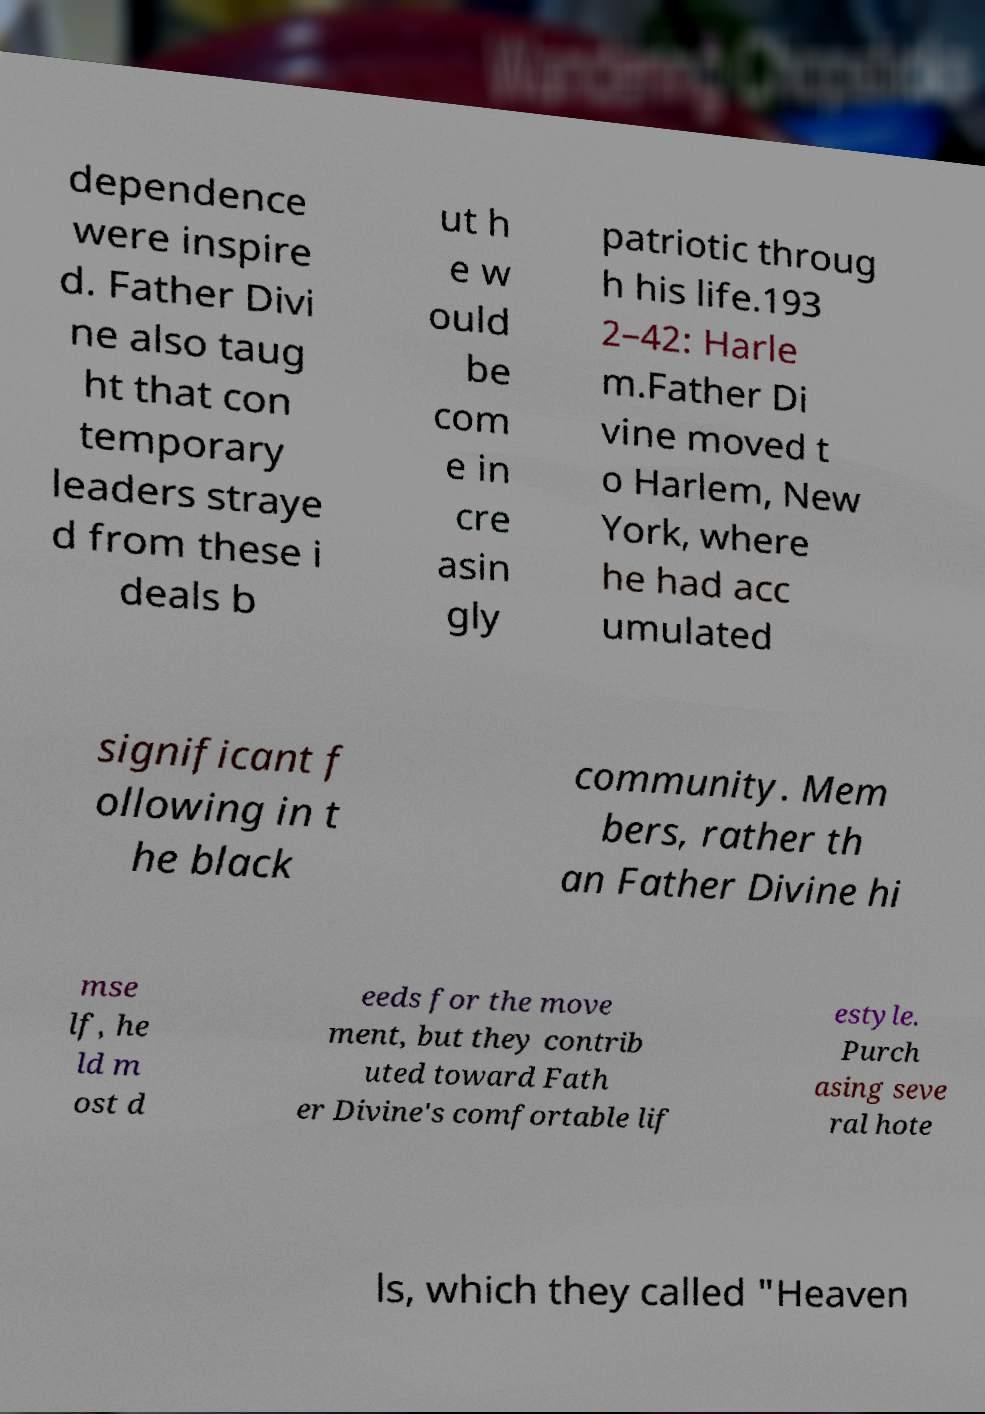Could you extract and type out the text from this image? dependence were inspire d. Father Divi ne also taug ht that con temporary leaders straye d from these i deals b ut h e w ould be com e in cre asin gly patriotic throug h his life.193 2–42: Harle m.Father Di vine moved t o Harlem, New York, where he had acc umulated significant f ollowing in t he black community. Mem bers, rather th an Father Divine hi mse lf, he ld m ost d eeds for the move ment, but they contrib uted toward Fath er Divine's comfortable lif estyle. Purch asing seve ral hote ls, which they called "Heaven 